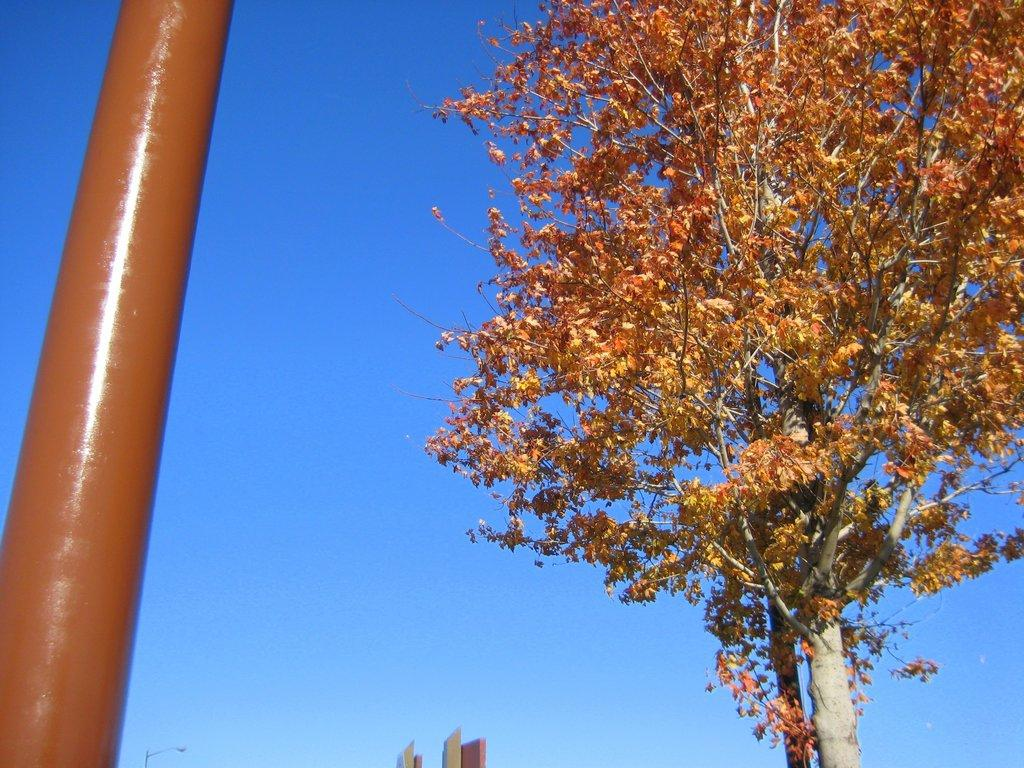What is one of the main structures in the image? There is a pole in the image. What type of natural element is present in the image? There is a tree in the image. What type of man-made structures can be seen in the image? There are buildings in the image. What is the color of the sky in the image? The sky is blue in the image. Based on the sky color, when do you think the image was taken? The image was likely taken during the day. What is causing the throat to feel crushed in the image? There is no mention of a throat or feeling of being crushed in the image. The image features a pole, a tree, buildings, the sky, and the time of day. 